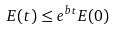Convert formula to latex. <formula><loc_0><loc_0><loc_500><loc_500>E ( t ) \leq e ^ { b t } E ( 0 )</formula> 